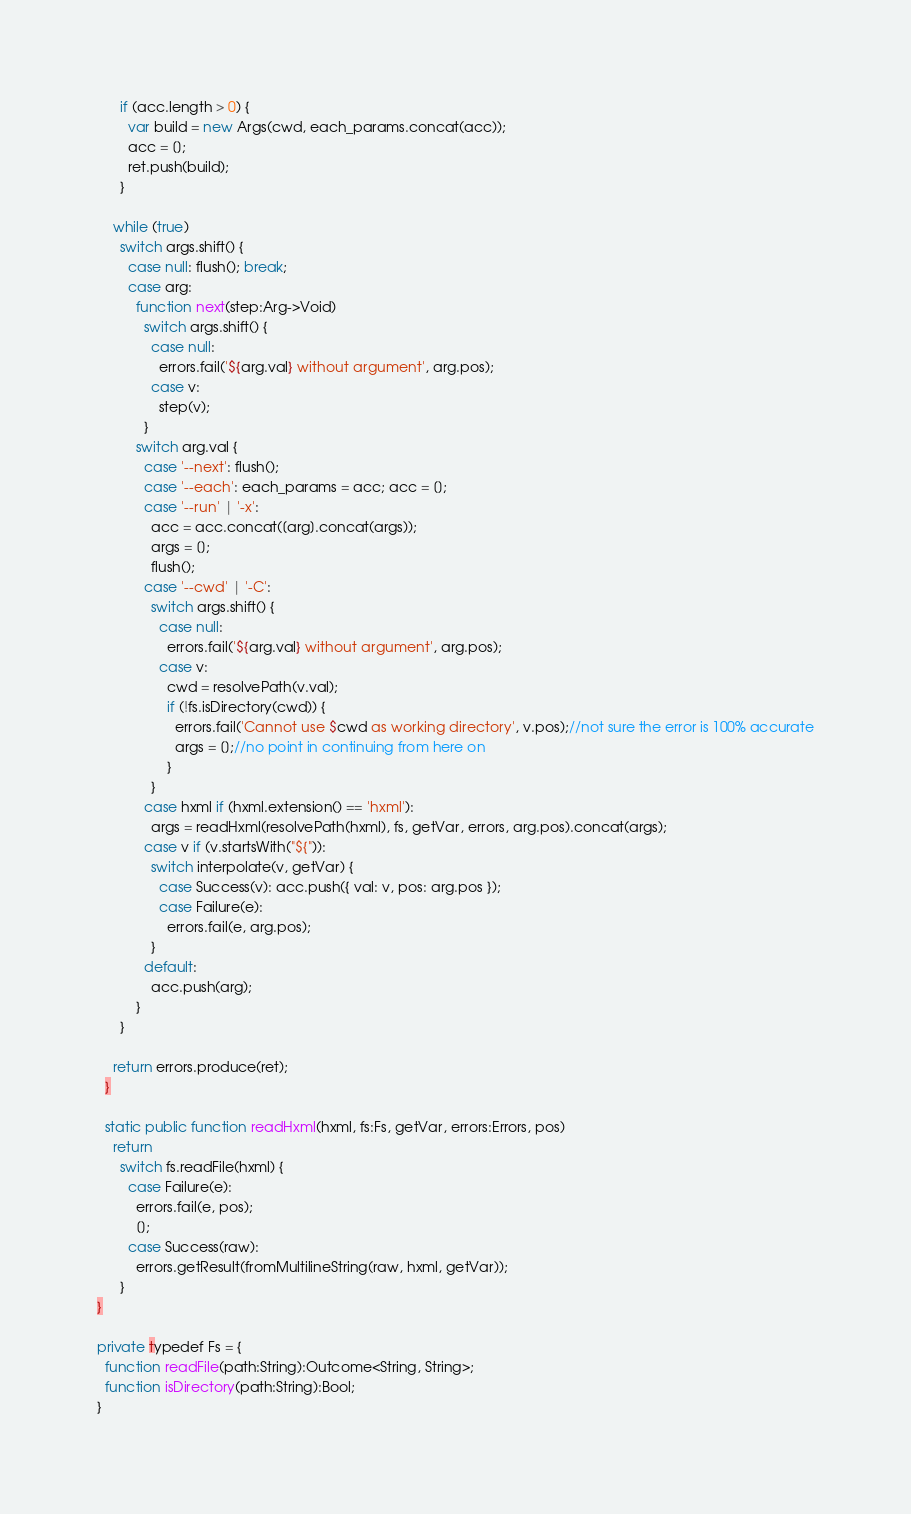<code> <loc_0><loc_0><loc_500><loc_500><_Haxe_>      if (acc.length > 0) {
        var build = new Args(cwd, each_params.concat(acc));
        acc = [];
        ret.push(build);
      }

    while (true)
      switch args.shift() {
        case null: flush(); break;
        case arg:
          function next(step:Arg->Void)
            switch args.shift() {
              case null:
                errors.fail('${arg.val} without argument', arg.pos);
              case v:
                step(v);
            }
          switch arg.val {
            case '--next': flush();
            case '--each': each_params = acc; acc = [];
            case '--run' | '-x':
              acc = acc.concat([arg].concat(args));
              args = [];
              flush();
            case '--cwd' | '-C':
              switch args.shift() {
                case null:
                  errors.fail('${arg.val} without argument', arg.pos);
                case v:
                  cwd = resolvePath(v.val);
                  if (!fs.isDirectory(cwd)) {
                    errors.fail('Cannot use $cwd as working directory', v.pos);//not sure the error is 100% accurate
                    args = [];//no point in continuing from here on
                  }
              }
            case hxml if (hxml.extension() == 'hxml'):
              args = readHxml(resolvePath(hxml), fs, getVar, errors, arg.pos).concat(args);
            case v if (v.startsWith("${")):
              switch interpolate(v, getVar) {
                case Success(v): acc.push({ val: v, pos: arg.pos });
                case Failure(e):
                  errors.fail(e, arg.pos);
              }
            default:
              acc.push(arg);
          }
      }

    return errors.produce(ret);
  }

  static public function readHxml(hxml, fs:Fs, getVar, errors:Errors, pos)
    return
      switch fs.readFile(hxml) {
        case Failure(e):
          errors.fail(e, pos);
          [];
        case Success(raw):
          errors.getResult(fromMultilineString(raw, hxml, getVar));
      }
}

private typedef Fs = {
  function readFile(path:String):Outcome<String, String>;
  function isDirectory(path:String):Bool;
}</code> 